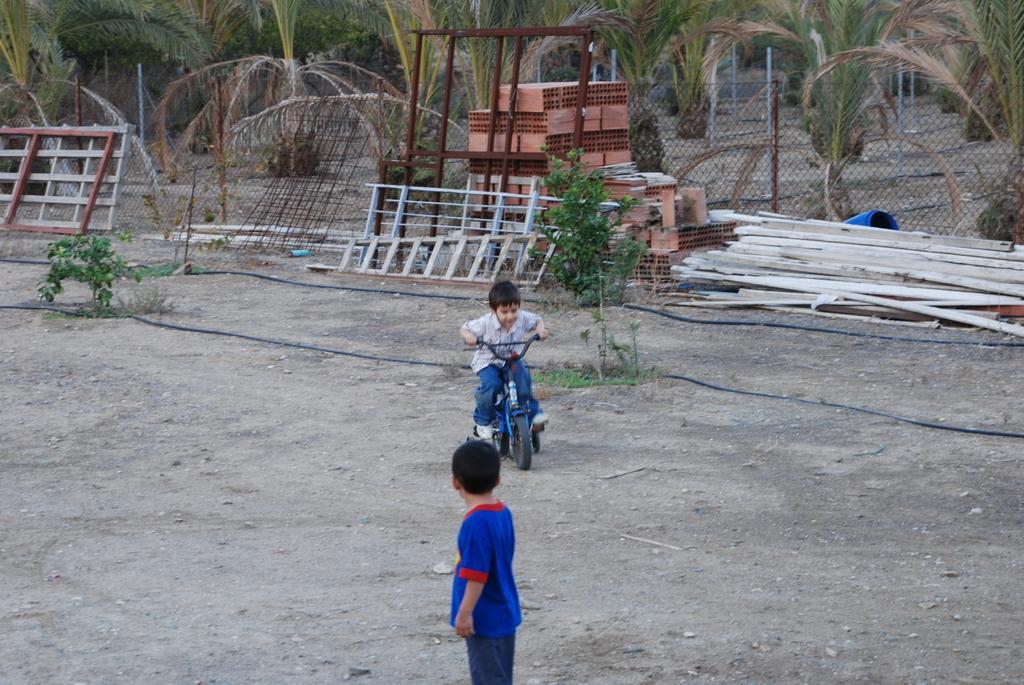Can you describe this image briefly? In the image I can see two children one on the bicycle. There are wires, wooden objects on the ground, and there are trees at the top of the image. 